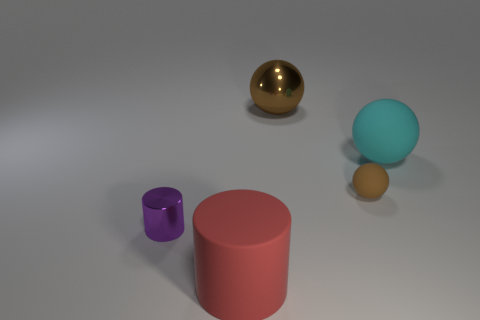Add 4 red matte things. How many objects exist? 9 Subtract all cylinders. How many objects are left? 3 Add 2 tiny balls. How many tiny balls are left? 3 Add 2 large cyan metallic cubes. How many large cyan metallic cubes exist? 2 Subtract 1 cyan spheres. How many objects are left? 4 Subtract all blue rubber cylinders. Subtract all small cylinders. How many objects are left? 4 